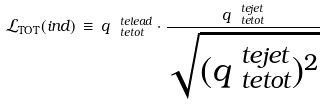<formula> <loc_0><loc_0><loc_500><loc_500>\mathcal { L } _ { \text {TOT} } ( i n d ) \, \equiv \, q ^ { \ t e { l e a d } } _ { \ t e { t o t } } \cdot \frac { q ^ { \ t e { j e t } } _ { \ t e { t o t } } } { \sqrt { ( q ^ { \ t e { j e t } } _ { \ t e { t o t } } ) ^ { 2 } } }</formula> 